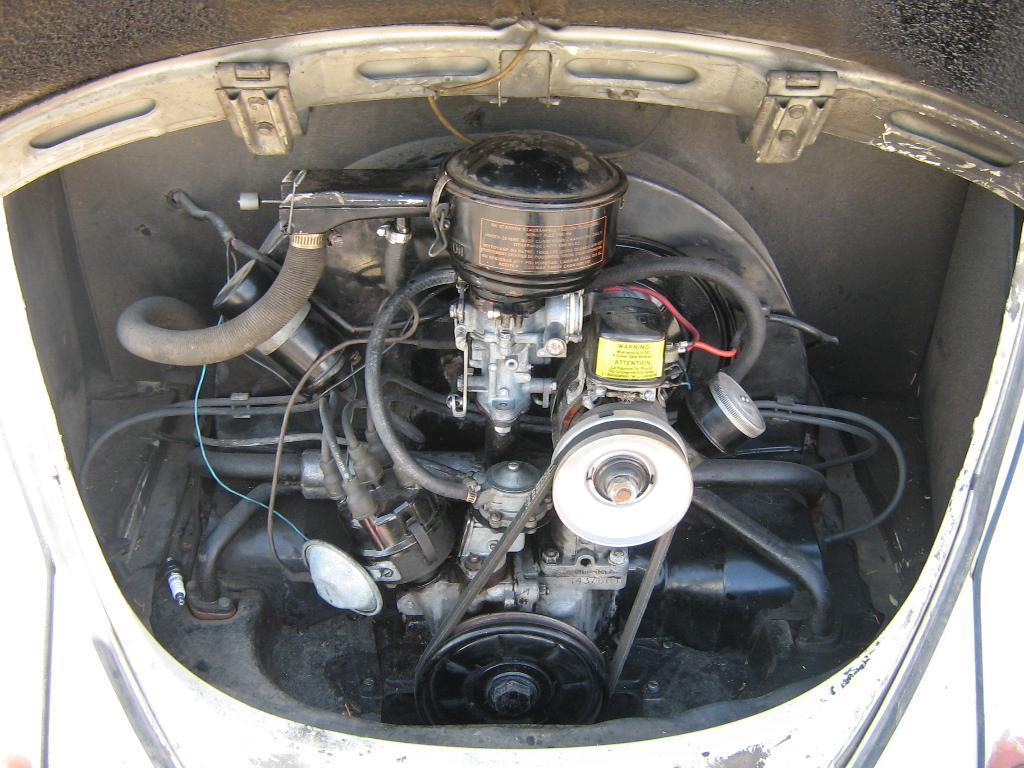What is the main subject of the image? The main subject of the image is an engine part of a vehicle. What day of the week is it according to the calendar in the image? There is no calendar present in the image, so it is not possible to determine the day of the week. 